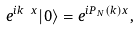<formula> <loc_0><loc_0><loc_500><loc_500>e ^ { i k \ x } | 0 \rangle = e ^ { i P _ { N } ( k ) x } ,</formula> 